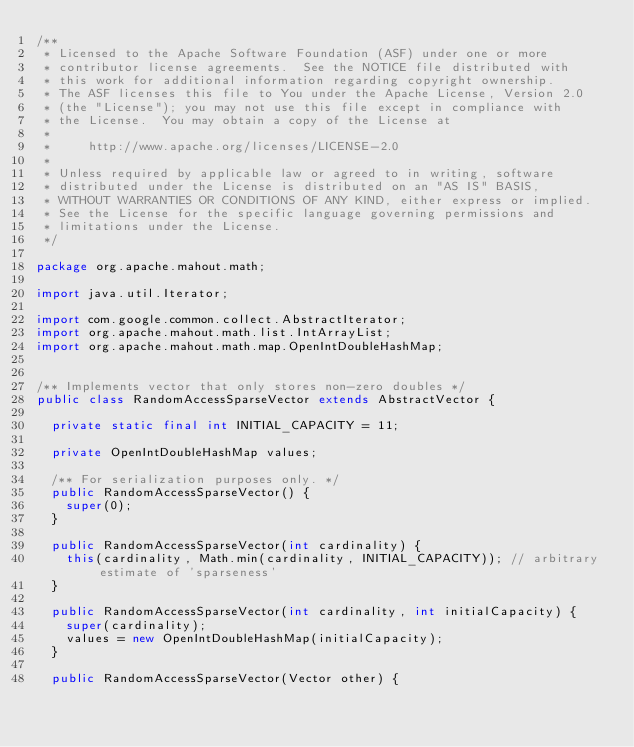Convert code to text. <code><loc_0><loc_0><loc_500><loc_500><_Java_>/**
 * Licensed to the Apache Software Foundation (ASF) under one or more
 * contributor license agreements.  See the NOTICE file distributed with
 * this work for additional information regarding copyright ownership.
 * The ASF licenses this file to You under the Apache License, Version 2.0
 * (the "License"); you may not use this file except in compliance with
 * the License.  You may obtain a copy of the License at
 *
 *     http://www.apache.org/licenses/LICENSE-2.0
 *
 * Unless required by applicable law or agreed to in writing, software
 * distributed under the License is distributed on an "AS IS" BASIS,
 * WITHOUT WARRANTIES OR CONDITIONS OF ANY KIND, either express or implied.
 * See the License for the specific language governing permissions and
 * limitations under the License.
 */

package org.apache.mahout.math;

import java.util.Iterator;

import com.google.common.collect.AbstractIterator;
import org.apache.mahout.math.list.IntArrayList;
import org.apache.mahout.math.map.OpenIntDoubleHashMap;


/** Implements vector that only stores non-zero doubles */
public class RandomAccessSparseVector extends AbstractVector {

  private static final int INITIAL_CAPACITY = 11;

  private OpenIntDoubleHashMap values;

  /** For serialization purposes only. */
  public RandomAccessSparseVector() {
    super(0);
  }

  public RandomAccessSparseVector(int cardinality) {
    this(cardinality, Math.min(cardinality, INITIAL_CAPACITY)); // arbitrary estimate of 'sparseness'
  }

  public RandomAccessSparseVector(int cardinality, int initialCapacity) {
    super(cardinality);
    values = new OpenIntDoubleHashMap(initialCapacity);
  }

  public RandomAccessSparseVector(Vector other) {</code> 